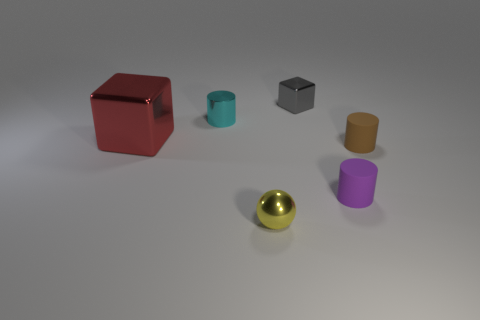Is the gray block made of the same material as the red thing?
Offer a terse response. Yes. What number of metal things are big blue cylinders or gray objects?
Provide a short and direct response. 1. What is the color of the block that is the same size as the purple thing?
Give a very brief answer. Gray. What number of other matte objects are the same shape as the small purple rubber thing?
Keep it short and to the point. 1. How many cylinders are small blue metallic things or gray things?
Give a very brief answer. 0. There is a rubber object that is on the right side of the purple object; does it have the same shape as the small matte thing that is in front of the brown rubber cylinder?
Ensure brevity in your answer.  Yes. What material is the cyan cylinder?
Provide a short and direct response. Metal. What number of yellow shiny blocks have the same size as the purple rubber thing?
Offer a very short reply. 0. How many things are either cylinders behind the large red metallic block or tiny metallic objects right of the tiny metallic sphere?
Provide a short and direct response. 2. Are the cube that is right of the cyan thing and the cylinder right of the tiny purple matte cylinder made of the same material?
Make the answer very short. No. 